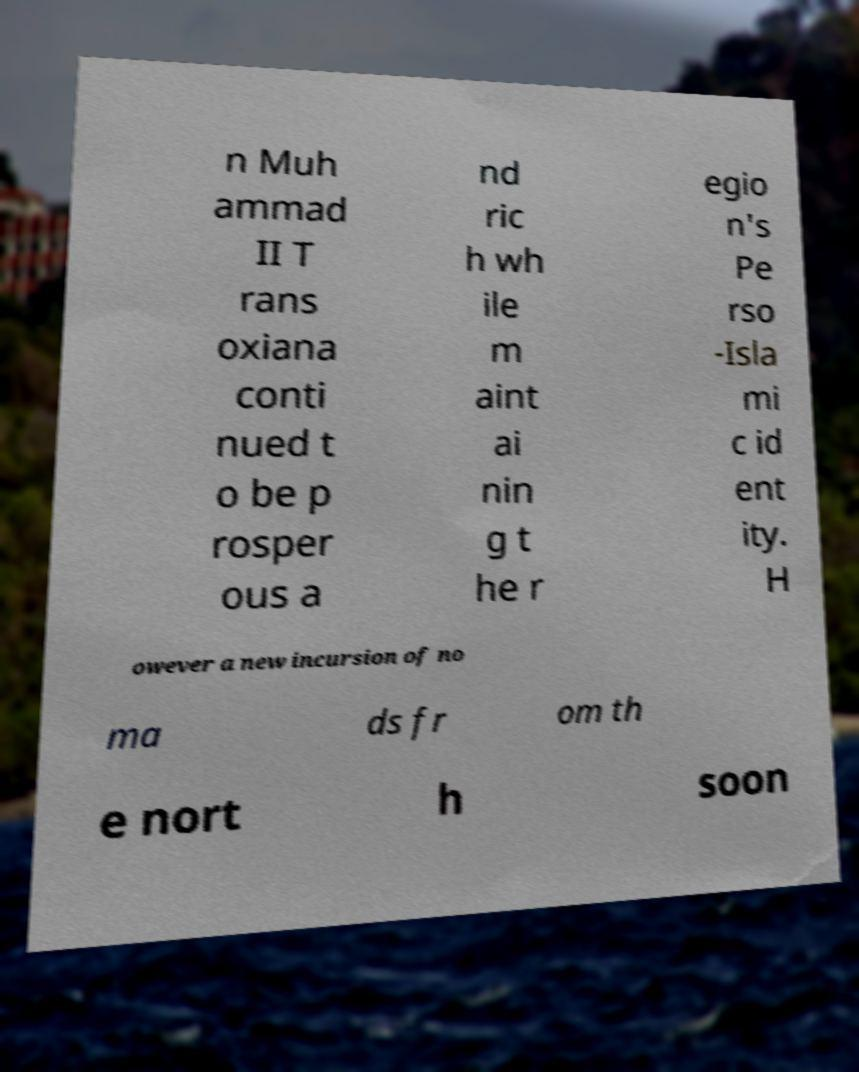There's text embedded in this image that I need extracted. Can you transcribe it verbatim? n Muh ammad II T rans oxiana conti nued t o be p rosper ous a nd ric h wh ile m aint ai nin g t he r egio n's Pe rso -Isla mi c id ent ity. H owever a new incursion of no ma ds fr om th e nort h soon 